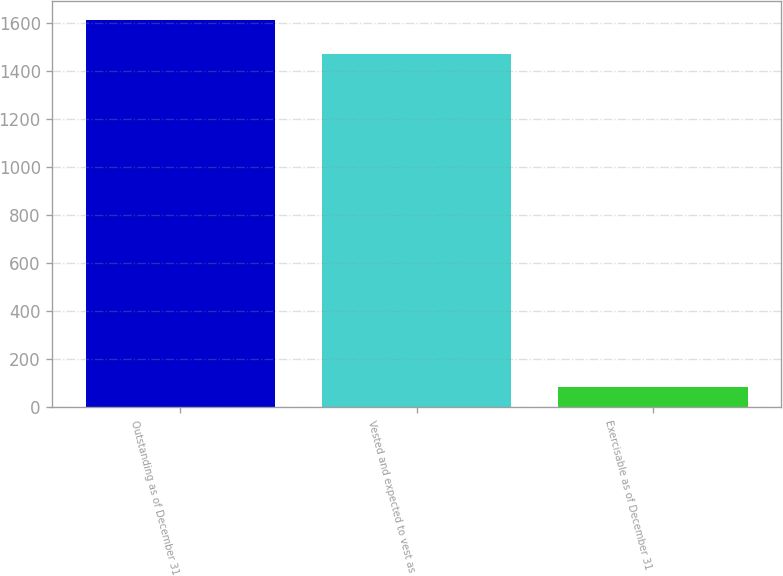Convert chart to OTSL. <chart><loc_0><loc_0><loc_500><loc_500><bar_chart><fcel>Outstanding as of December 31<fcel>Vested and expected to vest as<fcel>Exercisable as of December 31<nl><fcel>1610.3<fcel>1470<fcel>83<nl></chart> 